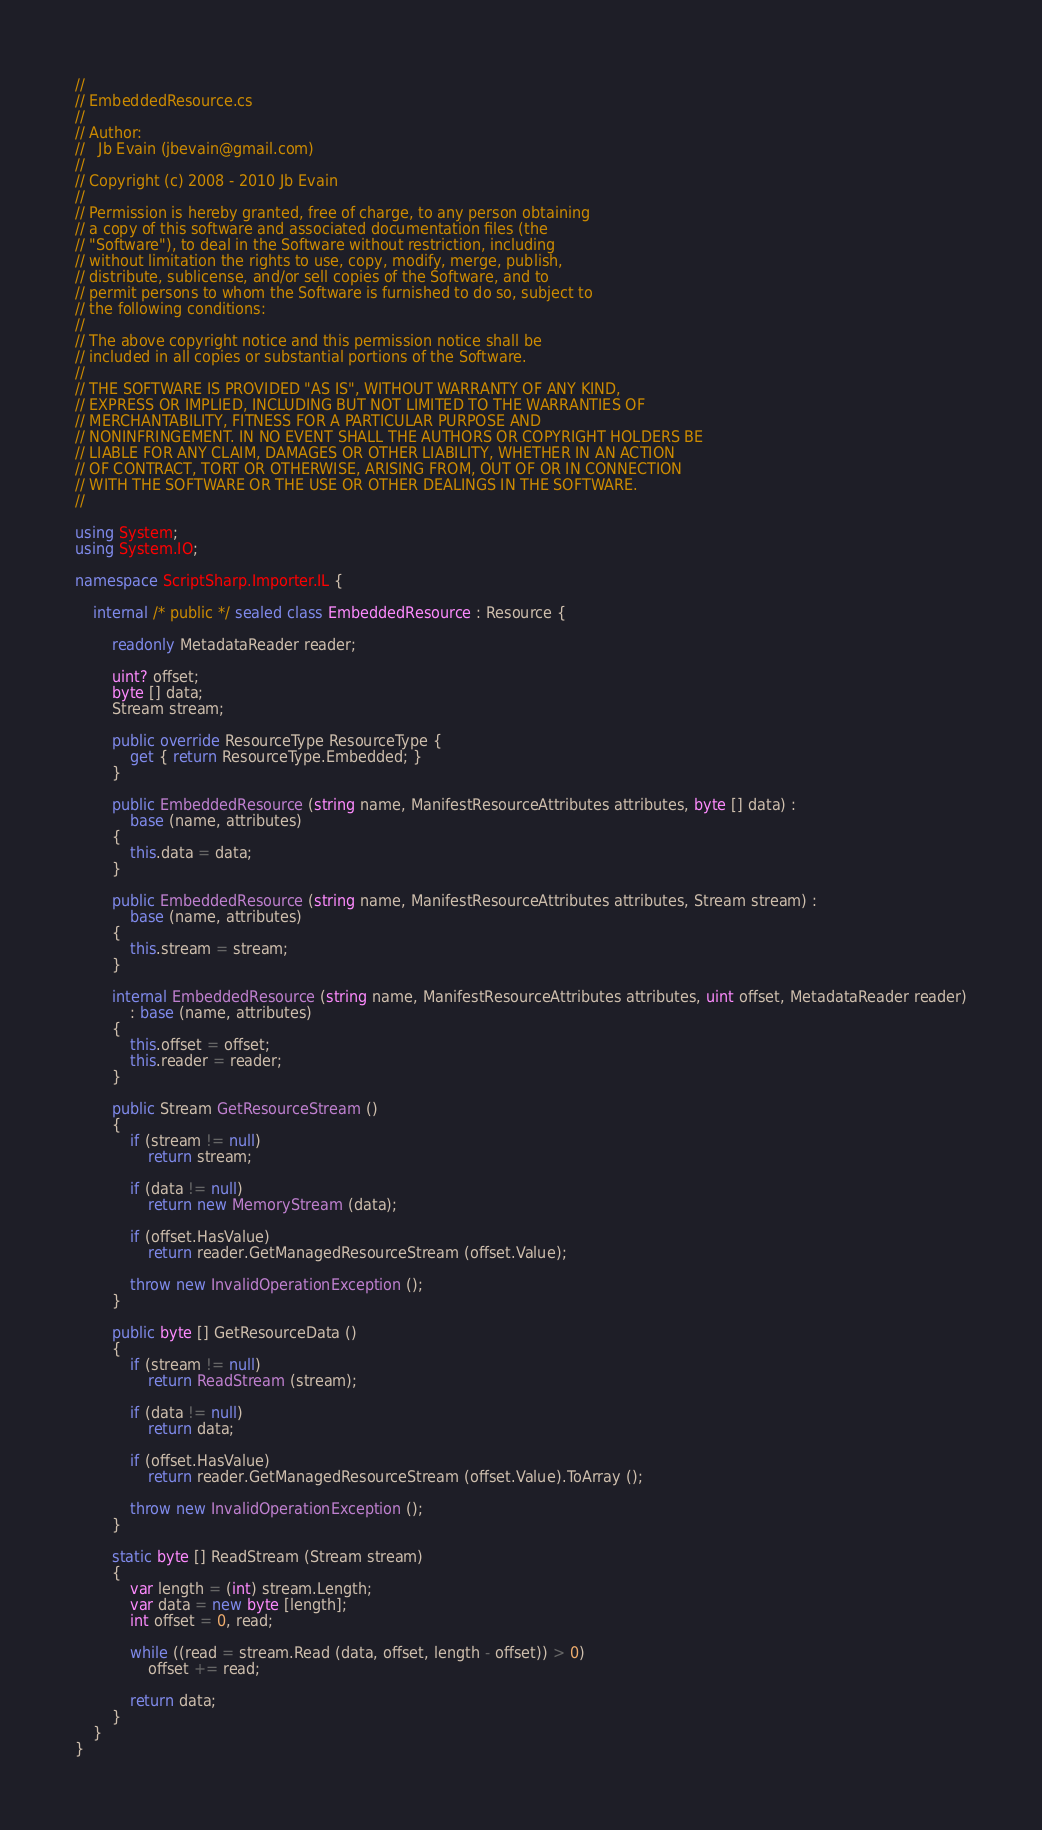Convert code to text. <code><loc_0><loc_0><loc_500><loc_500><_C#_>//
// EmbeddedResource.cs
//
// Author:
//   Jb Evain (jbevain@gmail.com)
//
// Copyright (c) 2008 - 2010 Jb Evain
//
// Permission is hereby granted, free of charge, to any person obtaining
// a copy of this software and associated documentation files (the
// "Software"), to deal in the Software without restriction, including
// without limitation the rights to use, copy, modify, merge, publish,
// distribute, sublicense, and/or sell copies of the Software, and to
// permit persons to whom the Software is furnished to do so, subject to
// the following conditions:
//
// The above copyright notice and this permission notice shall be
// included in all copies or substantial portions of the Software.
//
// THE SOFTWARE IS PROVIDED "AS IS", WITHOUT WARRANTY OF ANY KIND,
// EXPRESS OR IMPLIED, INCLUDING BUT NOT LIMITED TO THE WARRANTIES OF
// MERCHANTABILITY, FITNESS FOR A PARTICULAR PURPOSE AND
// NONINFRINGEMENT. IN NO EVENT SHALL THE AUTHORS OR COPYRIGHT HOLDERS BE
// LIABLE FOR ANY CLAIM, DAMAGES OR OTHER LIABILITY, WHETHER IN AN ACTION
// OF CONTRACT, TORT OR OTHERWISE, ARISING FROM, OUT OF OR IN CONNECTION
// WITH THE SOFTWARE OR THE USE OR OTHER DEALINGS IN THE SOFTWARE.
//

using System;
using System.IO;

namespace ScriptSharp.Importer.IL {

    internal /* public */ sealed class EmbeddedResource : Resource {

		readonly MetadataReader reader;

		uint? offset;
		byte [] data;
		Stream stream;

		public override ResourceType ResourceType {
			get { return ResourceType.Embedded; }
		}

		public EmbeddedResource (string name, ManifestResourceAttributes attributes, byte [] data) :
			base (name, attributes)
		{
			this.data = data;
		}

		public EmbeddedResource (string name, ManifestResourceAttributes attributes, Stream stream) :
			base (name, attributes)
		{
			this.stream = stream;
		}

		internal EmbeddedResource (string name, ManifestResourceAttributes attributes, uint offset, MetadataReader reader)
			: base (name, attributes)
		{
			this.offset = offset;
			this.reader = reader;
		}

		public Stream GetResourceStream ()
		{
			if (stream != null)
				return stream;

			if (data != null)
				return new MemoryStream (data);

			if (offset.HasValue)
				return reader.GetManagedResourceStream (offset.Value);

			throw new InvalidOperationException ();
		}

		public byte [] GetResourceData ()
		{
			if (stream != null)
				return ReadStream (stream);

			if (data != null)
				return data;

			if (offset.HasValue)
				return reader.GetManagedResourceStream (offset.Value).ToArray ();

			throw new InvalidOperationException ();
		}

		static byte [] ReadStream (Stream stream)
		{
			var length = (int) stream.Length;
			var data = new byte [length];
			int offset = 0, read;

			while ((read = stream.Read (data, offset, length - offset)) > 0)
				offset += read;

			return data;
		}
	}
}
</code> 